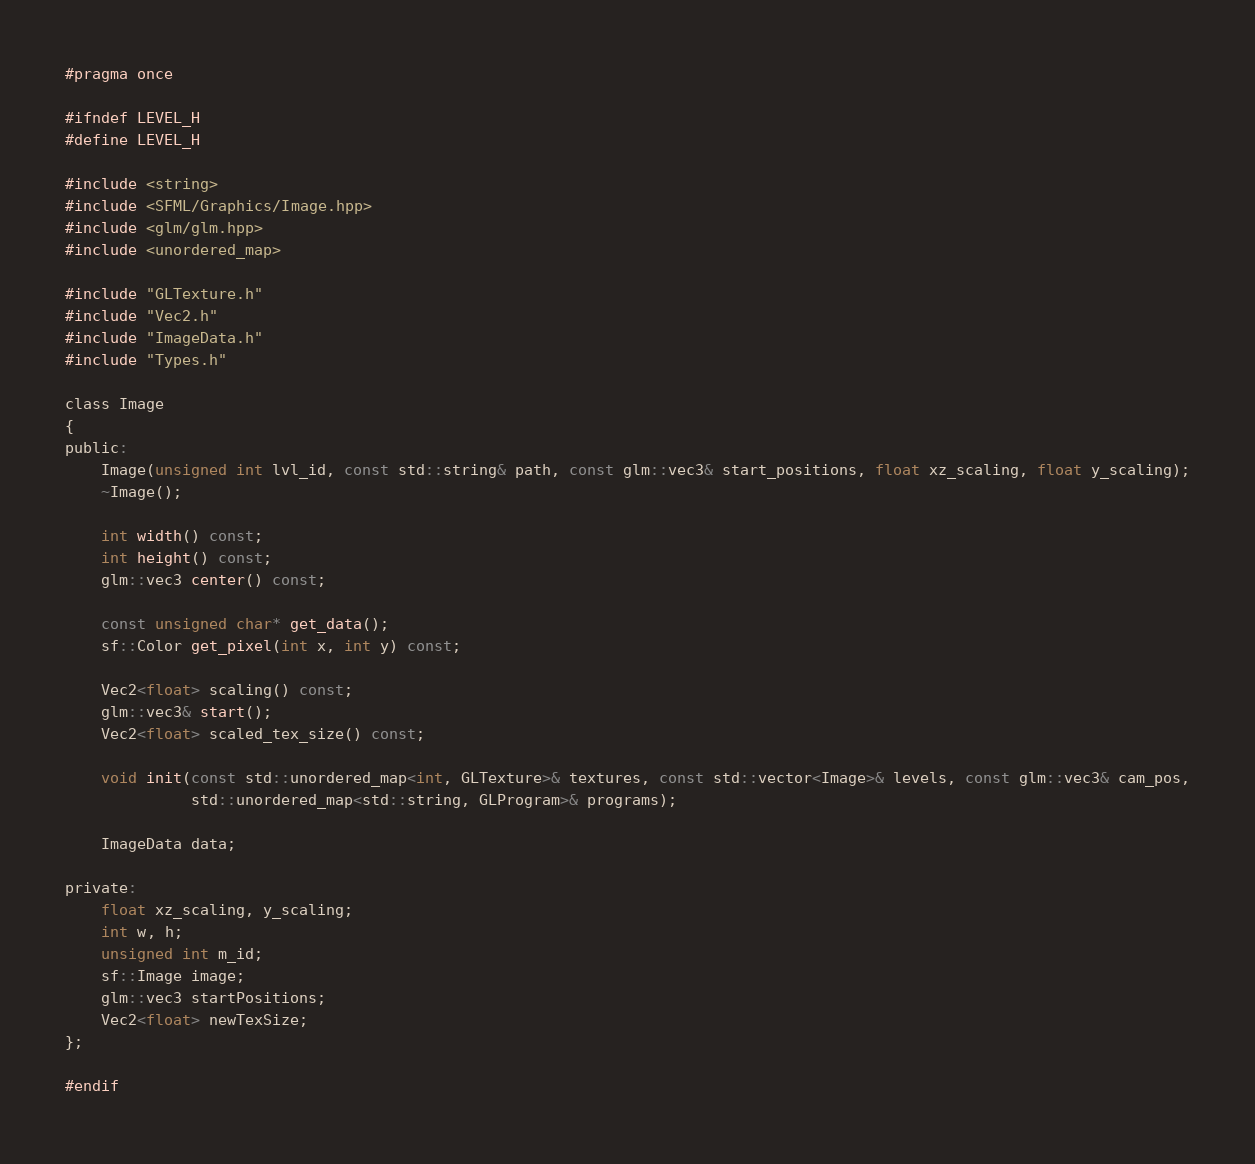Convert code to text. <code><loc_0><loc_0><loc_500><loc_500><_C_>#pragma once

#ifndef LEVEL_H
#define LEVEL_H

#include <string>
#include <SFML/Graphics/Image.hpp>
#include <glm/glm.hpp>
#include <unordered_map>

#include "GLTexture.h"
#include "Vec2.h"
#include "ImageData.h"
#include "Types.h"

class Image
{
public:
    Image(unsigned int lvl_id, const std::string& path, const glm::vec3& start_positions, float xz_scaling, float y_scaling);
    ~Image();

    int width() const;
    int height() const;
    glm::vec3 center() const;

    const unsigned char* get_data();
    sf::Color get_pixel(int x, int y) const;

    Vec2<float> scaling() const;
    glm::vec3& start();
    Vec2<float> scaled_tex_size() const;

    void init(const std::unordered_map<int, GLTexture>& textures, const std::vector<Image>& levels, const glm::vec3& cam_pos,
              std::unordered_map<std::string, GLProgram>& programs);

    ImageData data;

private:
    float xz_scaling, y_scaling;
    int w, h;
    unsigned int m_id;
    sf::Image image;
    glm::vec3 startPositions;
    Vec2<float> newTexSize;
};

#endif</code> 